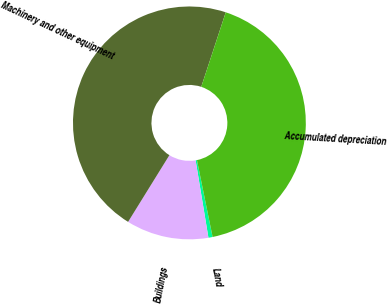Convert chart to OTSL. <chart><loc_0><loc_0><loc_500><loc_500><pie_chart><fcel>Land<fcel>Buildings<fcel>Machinery and other equipment<fcel>Accumulated depreciation<nl><fcel>0.58%<fcel>11.44%<fcel>46.23%<fcel>41.75%<nl></chart> 